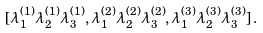<formula> <loc_0><loc_0><loc_500><loc_500>[ \lambda _ { 1 } ^ { ( 1 ) } \lambda _ { 2 } ^ { ( 1 ) } \lambda _ { 3 } ^ { ( 1 ) } , \lambda _ { 1 } ^ { ( 2 ) } \lambda _ { 2 } ^ { ( 2 ) } \lambda _ { 3 } ^ { ( 2 ) } , \lambda _ { 1 } ^ { ( 3 ) } \lambda _ { 2 } ^ { ( 3 ) } \lambda _ { 3 } ^ { ( 3 ) } ] \, .</formula> 